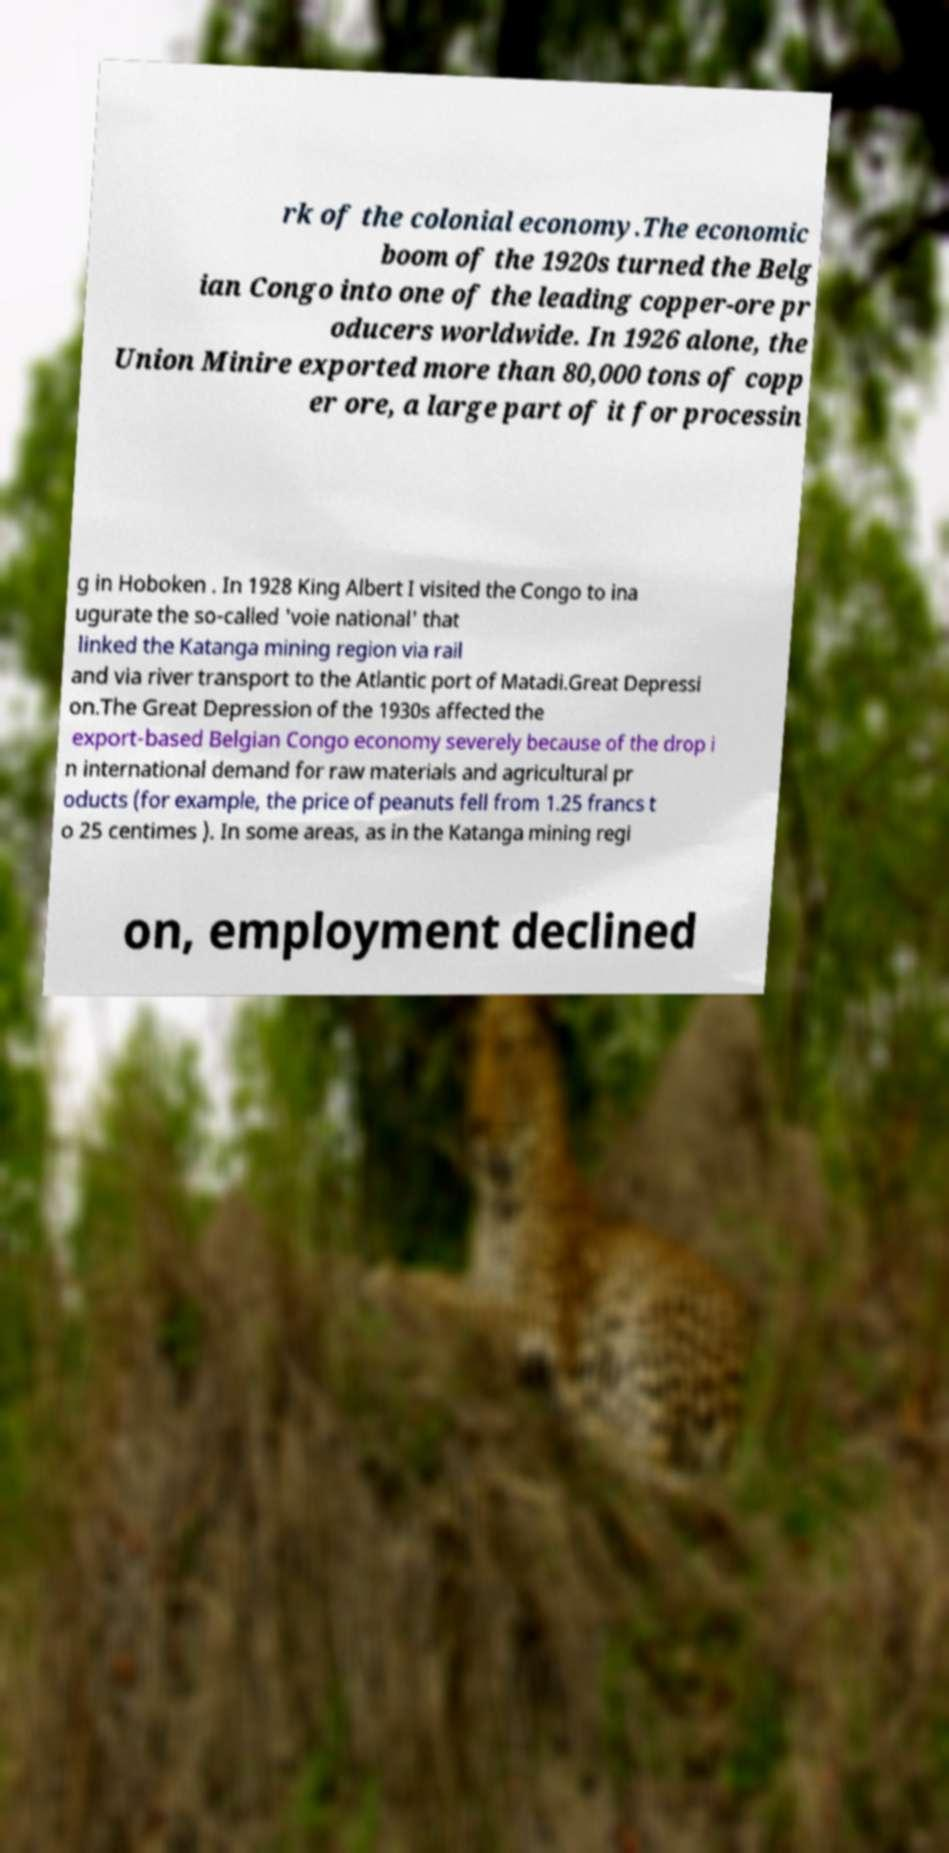Please read and relay the text visible in this image. What does it say? rk of the colonial economy.The economic boom of the 1920s turned the Belg ian Congo into one of the leading copper-ore pr oducers worldwide. In 1926 alone, the Union Minire exported more than 80,000 tons of copp er ore, a large part of it for processin g in Hoboken . In 1928 King Albert I visited the Congo to ina ugurate the so-called 'voie national' that linked the Katanga mining region via rail and via river transport to the Atlantic port of Matadi.Great Depressi on.The Great Depression of the 1930s affected the export-based Belgian Congo economy severely because of the drop i n international demand for raw materials and agricultural pr oducts (for example, the price of peanuts fell from 1.25 francs t o 25 centimes ). In some areas, as in the Katanga mining regi on, employment declined 